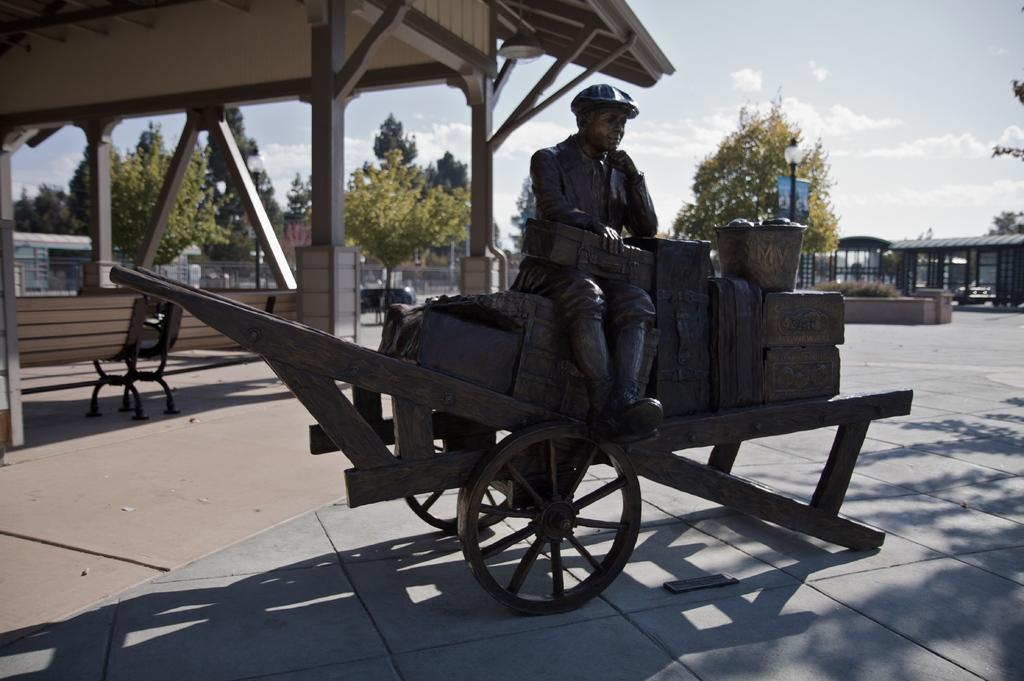What is the main subject of the image? There is a statue of a man in the image. What is the man sitting on in the image? The man is sitting on luggage on a carriage. What can be seen in the background of the image? There is a shed and trees in the background of the image. What is visible in the sky in the image? The sky is visible in the image, and clouds are present. What time of day does the man sense the morning in the image? There is no indication of time of day or the man's ability to sense in the image. 